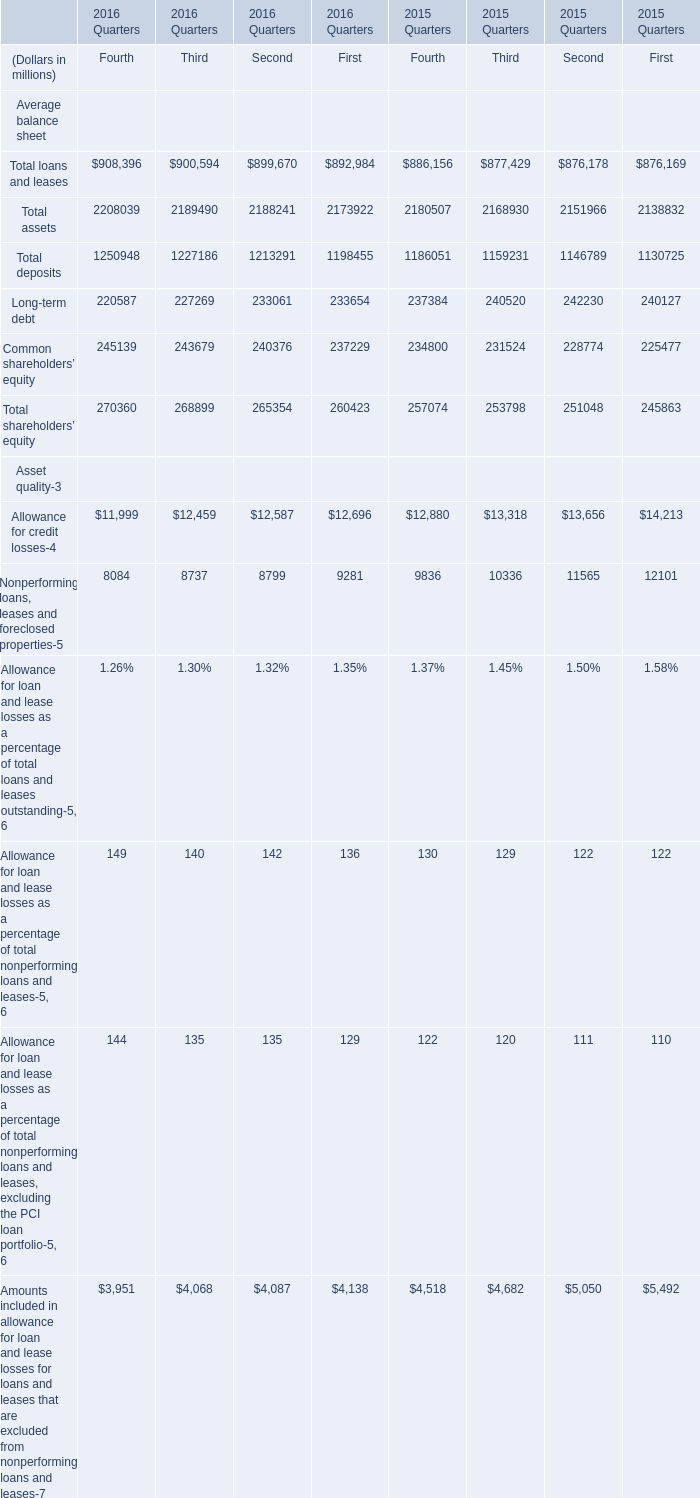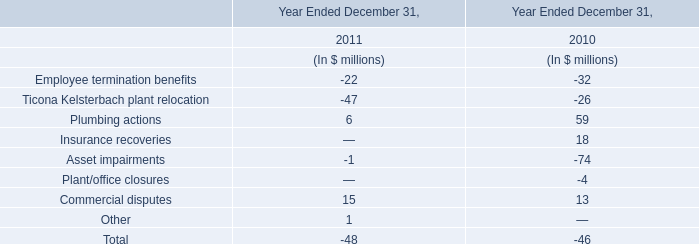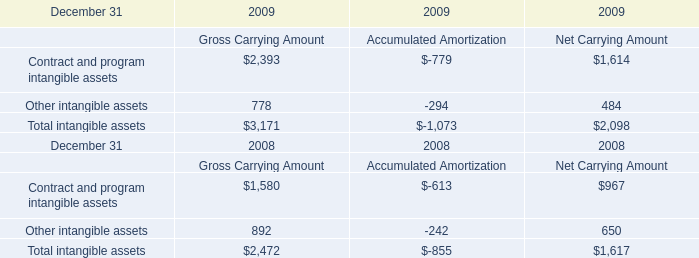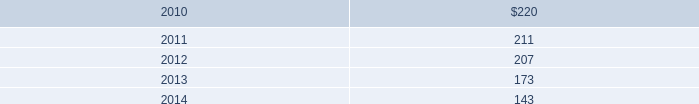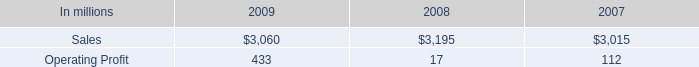north american consumer packaging net sales where what percentage of consumer packaging sales in 2008? 
Computations: ((2.5 * 1000) / 3195)
Answer: 0.78247. 